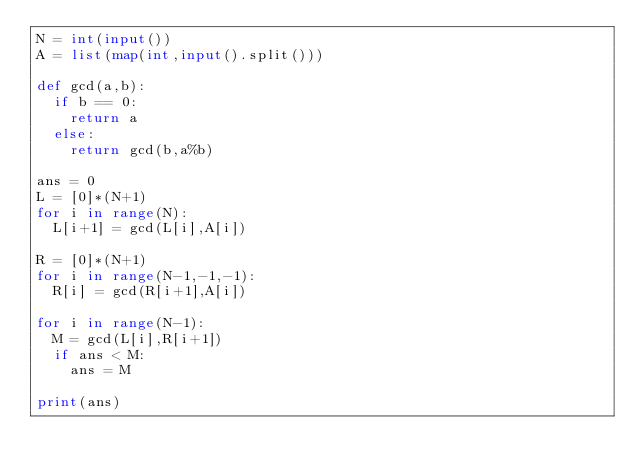<code> <loc_0><loc_0><loc_500><loc_500><_Python_>N = int(input())
A = list(map(int,input().split()))

def gcd(a,b):
  if b == 0:
    return a
  else:
    return gcd(b,a%b)

ans = 0
L = [0]*(N+1)
for i in range(N):
  L[i+1] = gcd(L[i],A[i])
  
R = [0]*(N+1)
for i in range(N-1,-1,-1):
  R[i] = gcd(R[i+1],A[i])
  
for i in range(N-1):
  M = gcd(L[i],R[i+1])
  if ans < M:
    ans = M
    
print(ans)</code> 